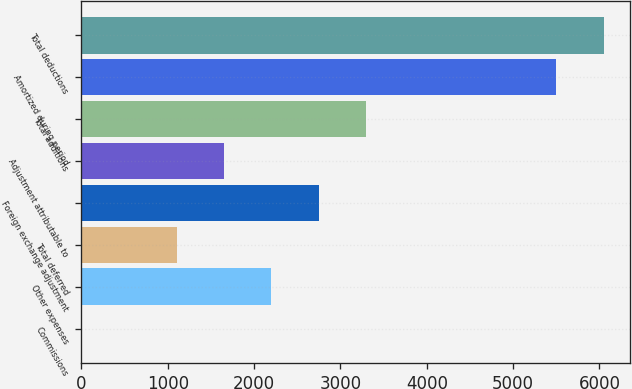Convert chart. <chart><loc_0><loc_0><loc_500><loc_500><bar_chart><fcel>Commissions<fcel>Other expenses<fcel>Total deferred<fcel>Foreign exchange adjustment<fcel>Adjustment attributable to<fcel>Total additions<fcel>Amortized during period<fcel>Total deductions<nl><fcel>1.01<fcel>2201.01<fcel>1101.01<fcel>2751.01<fcel>1651.01<fcel>3301.01<fcel>5501<fcel>6051<nl></chart> 